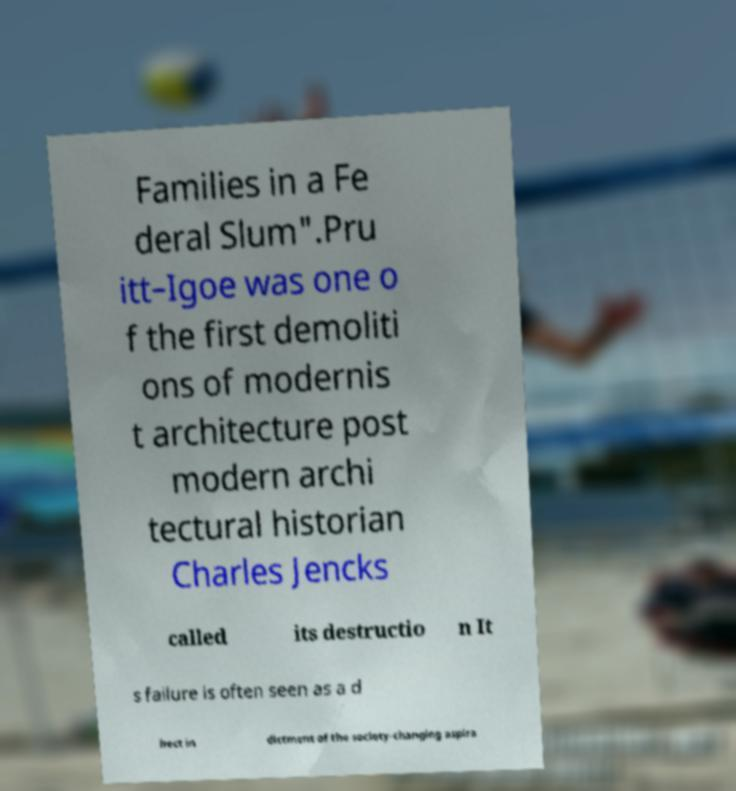Please read and relay the text visible in this image. What does it say? Families in a Fe deral Slum".Pru itt–Igoe was one o f the first demoliti ons of modernis t architecture post modern archi tectural historian Charles Jencks called its destructio n It s failure is often seen as a d irect in dictment of the society-changing aspira 